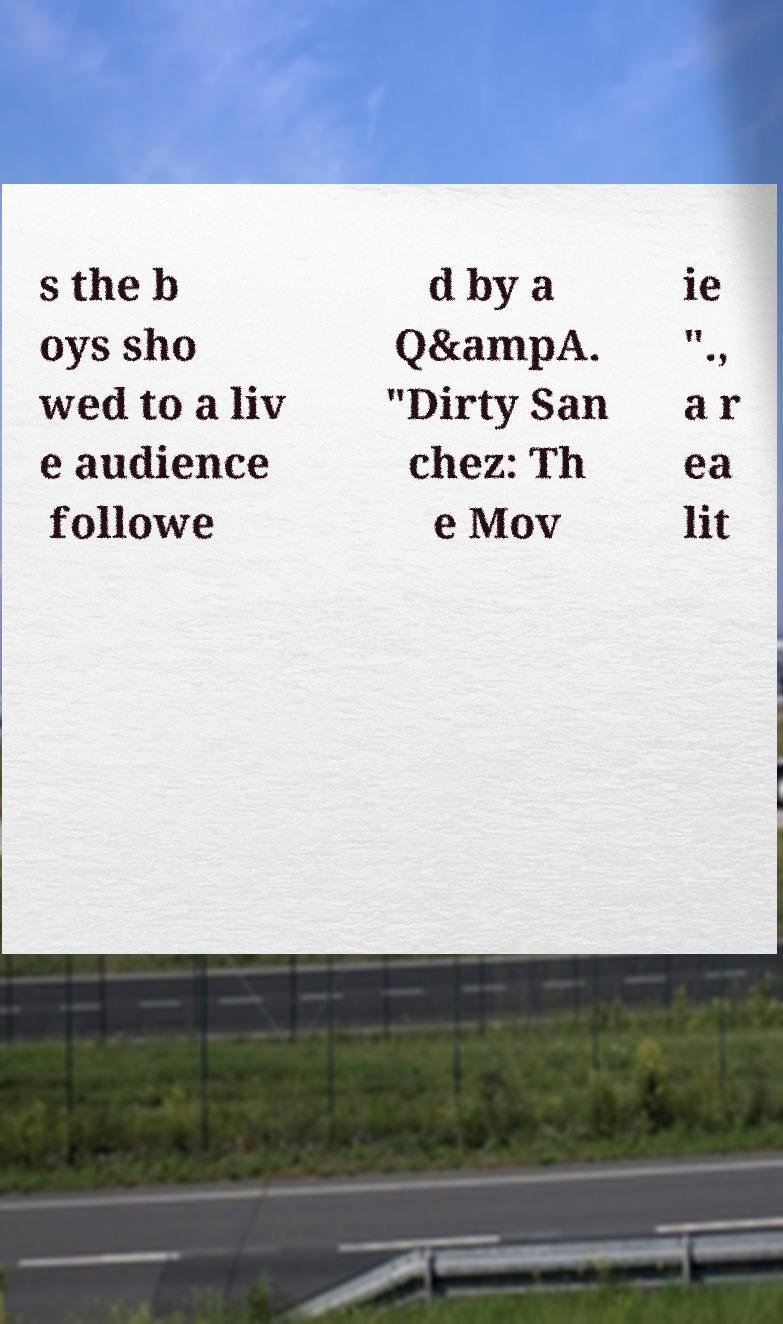What messages or text are displayed in this image? I need them in a readable, typed format. s the b oys sho wed to a liv e audience followe d by a Q&ampA. "Dirty San chez: Th e Mov ie "., a r ea lit 